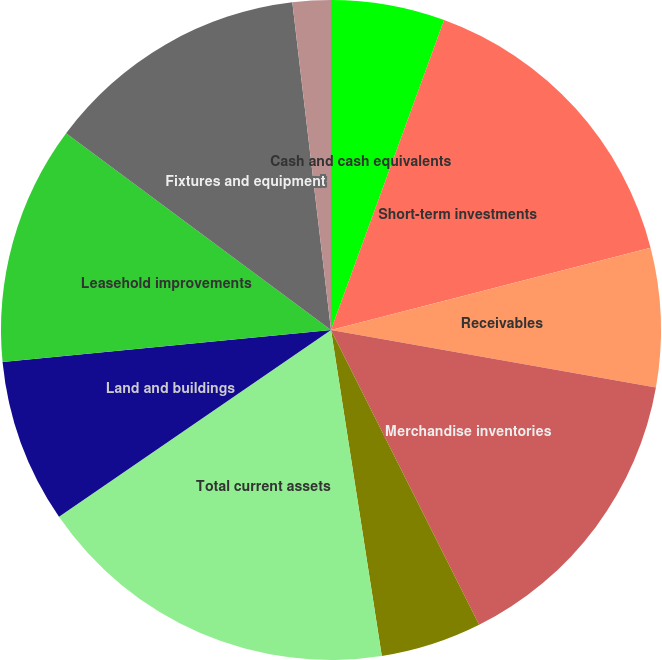Convert chart. <chart><loc_0><loc_0><loc_500><loc_500><pie_chart><fcel>Cash and cash equivalents<fcel>Short-term investments<fcel>Receivables<fcel>Merchandise inventories<fcel>Other current assets<fcel>Total current assets<fcel>Land and buildings<fcel>Leasehold improvements<fcel>Fixtures and equipment<fcel>Property under master and<nl><fcel>5.57%<fcel>15.42%<fcel>6.8%<fcel>14.8%<fcel>4.95%<fcel>17.88%<fcel>8.03%<fcel>11.72%<fcel>12.96%<fcel>1.87%<nl></chart> 